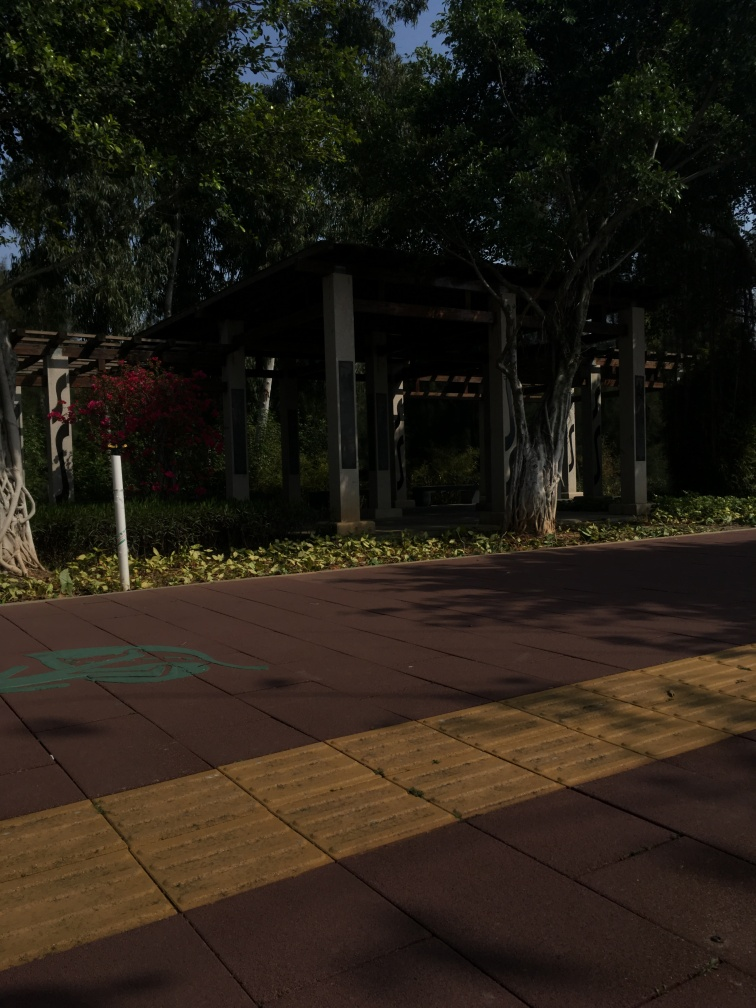Can you describe the environment and the mood this image evokes? The image portrays a peaceful outdoor setting, likely a park or a similar recreational area. The vibrant greenery, including lush trees and flowering shrubs, contributes to a serene and inviting atmosphere. The path with tactile paving suggests this area is well-considered for accessibility. The clear sky and the shadows cast by the trees suggest a sunny day. The overall mood evoked is one of tranquility and the simplicity of connecting with nature in an urban setting. 